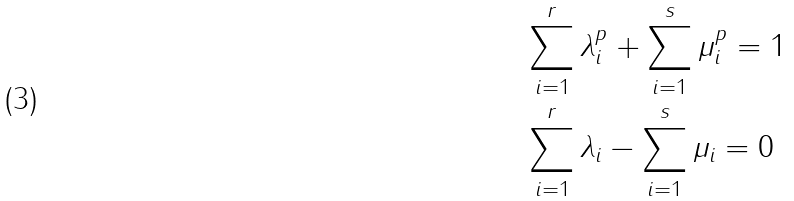Convert formula to latex. <formula><loc_0><loc_0><loc_500><loc_500>& \sum _ { i = 1 } ^ { r } \lambda _ { i } ^ { p } + \sum _ { i = 1 } ^ { s } \mu _ { i } ^ { p } = 1 \\ & \sum _ { i = 1 } ^ { r } \lambda _ { i } - \sum _ { i = 1 } ^ { s } \mu _ { i } = 0</formula> 